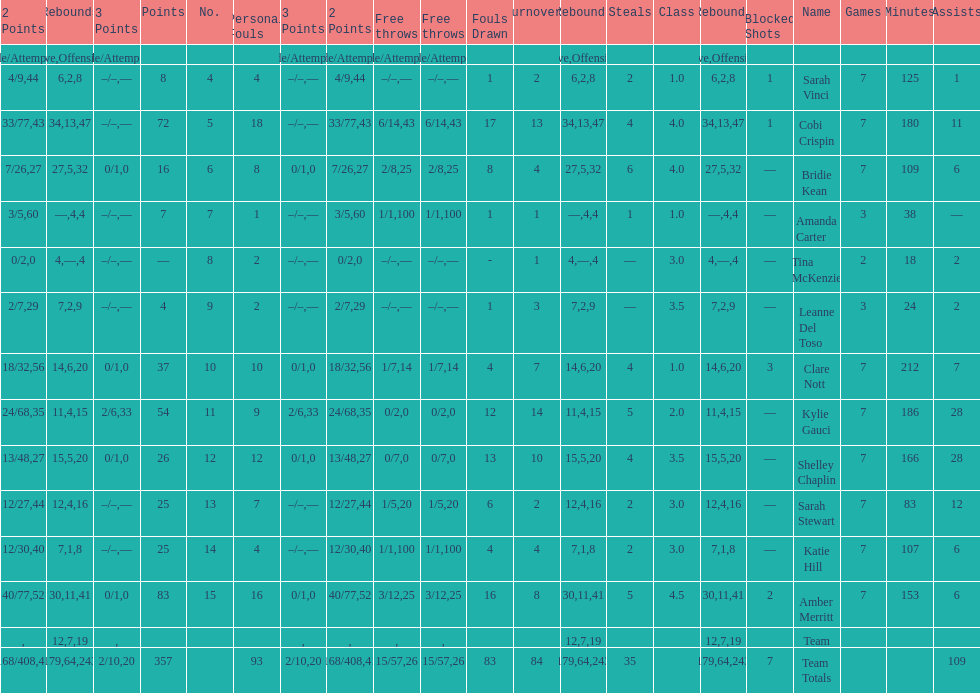After playing seven games, how many players individual points were above 30? 4. 